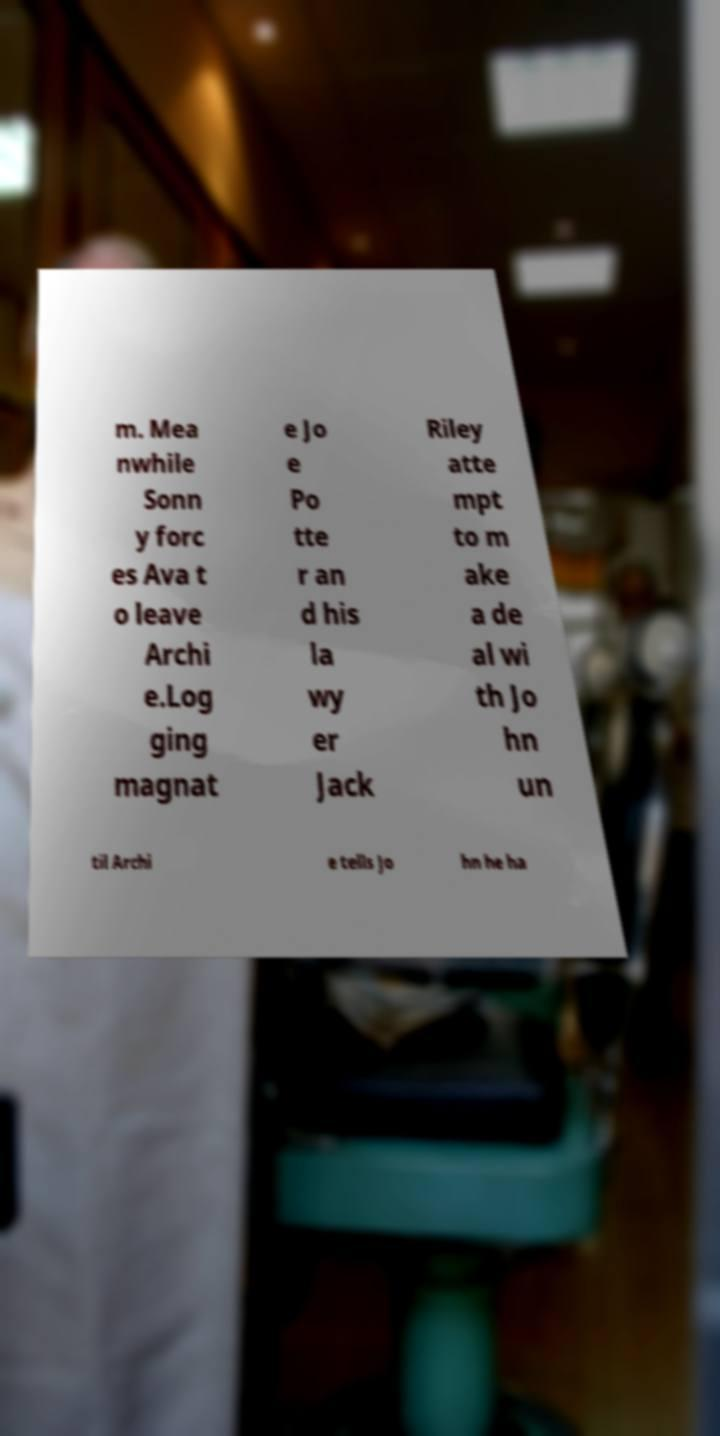Could you extract and type out the text from this image? m. Mea nwhile Sonn y forc es Ava t o leave Archi e.Log ging magnat e Jo e Po tte r an d his la wy er Jack Riley atte mpt to m ake a de al wi th Jo hn un til Archi e tells Jo hn he ha 